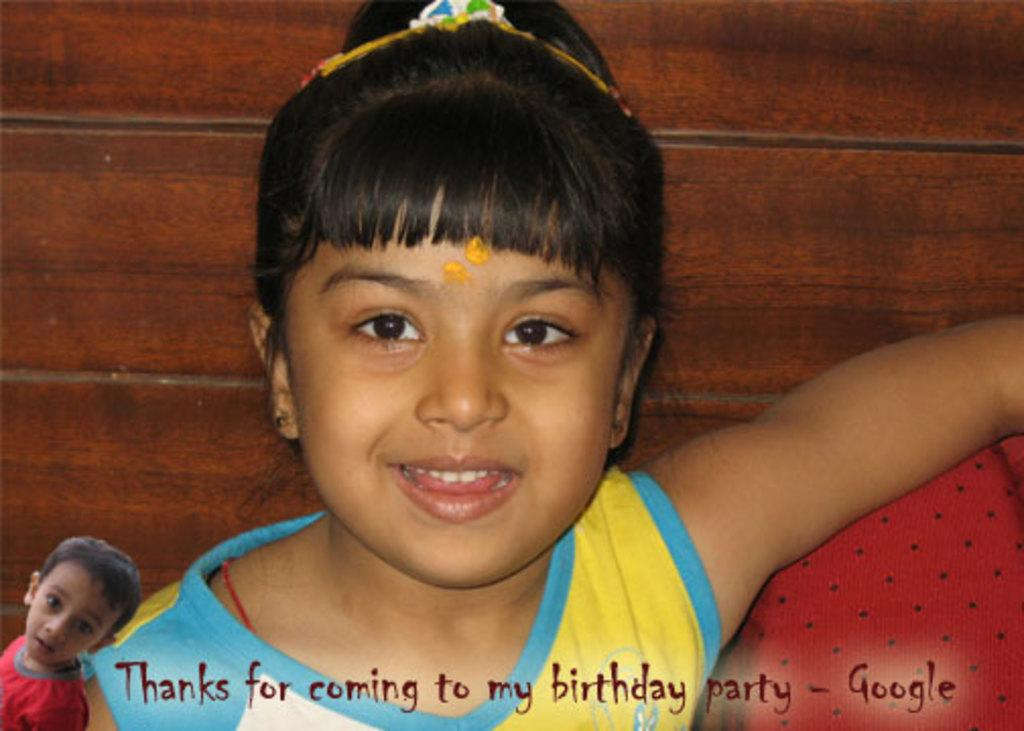Who is the main subject in the image? There is a girl in the image. What is the girl doing in the image? The girl is sitting on a sofa. What type of tax is being discussed in the image? There is no mention or indication of any tax-related discussion in the image. 